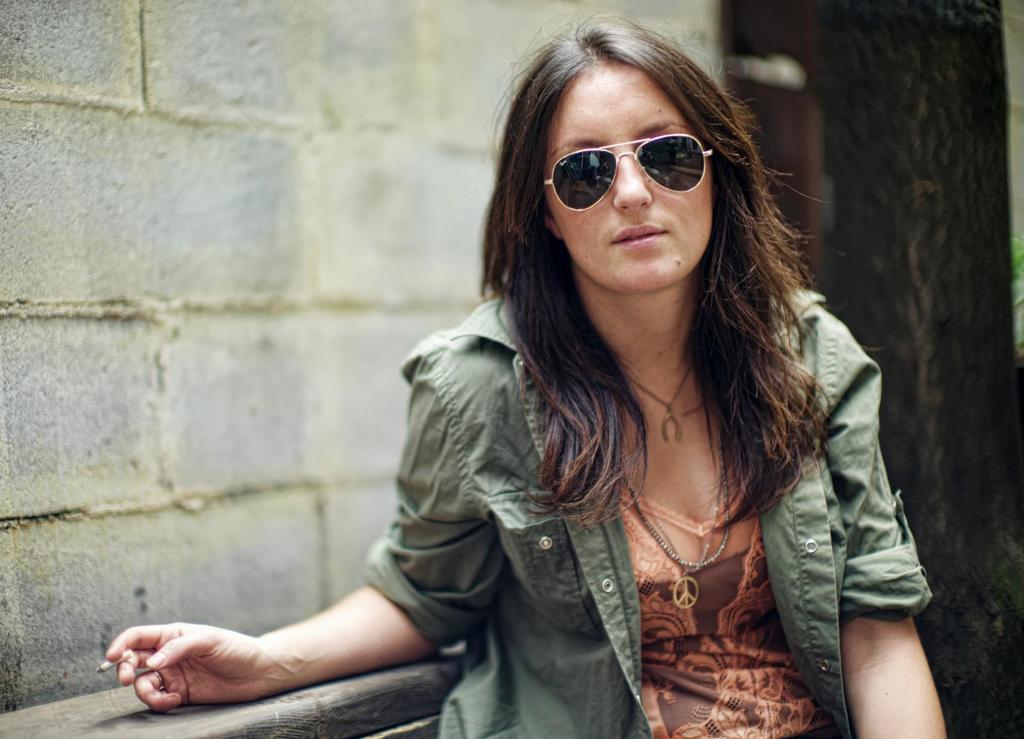Who is the main subject in the image? There is a woman in the image. What is the woman wearing? The woman is wearing a green jacket. What is the woman doing in the image? The woman is giggling. What is the woman holding in her hands? The woman is holding a cigarette in her hands. Where is the woman standing in the image? The woman is standing near a wall. What type of soda is the woman drinking in the image? There is no soda present in the image; the woman is holding a cigarette. Can you see a patch on the woman's jacket in the image? There is no mention of a patch on the woman's jacket in the provided facts, so we cannot determine if one is present. 